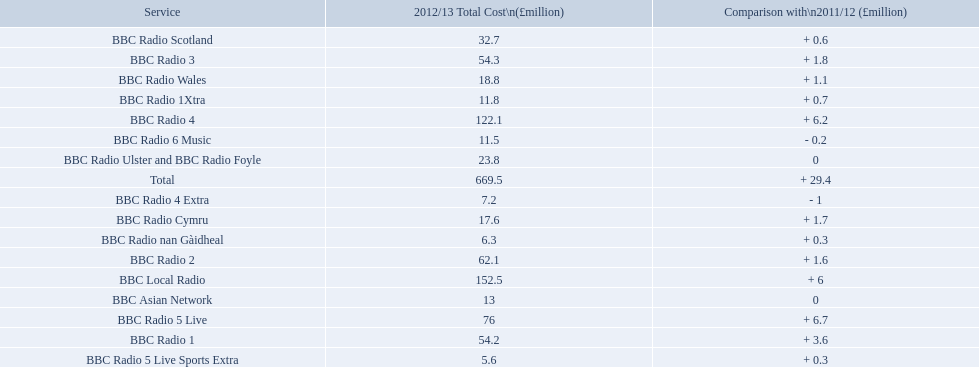Which services are there for bbc radio? BBC Radio 1, BBC Radio 1Xtra, BBC Radio 2, BBC Radio 3, BBC Radio 4, BBC Radio 4 Extra, BBC Radio 5 Live, BBC Radio 5 Live Sports Extra, BBC Radio 6 Music, BBC Asian Network, BBC Local Radio, BBC Radio Scotland, BBC Radio nan Gàidheal, BBC Radio Wales, BBC Radio Cymru, BBC Radio Ulster and BBC Radio Foyle. Of those which one had the highest cost? BBC Local Radio. 